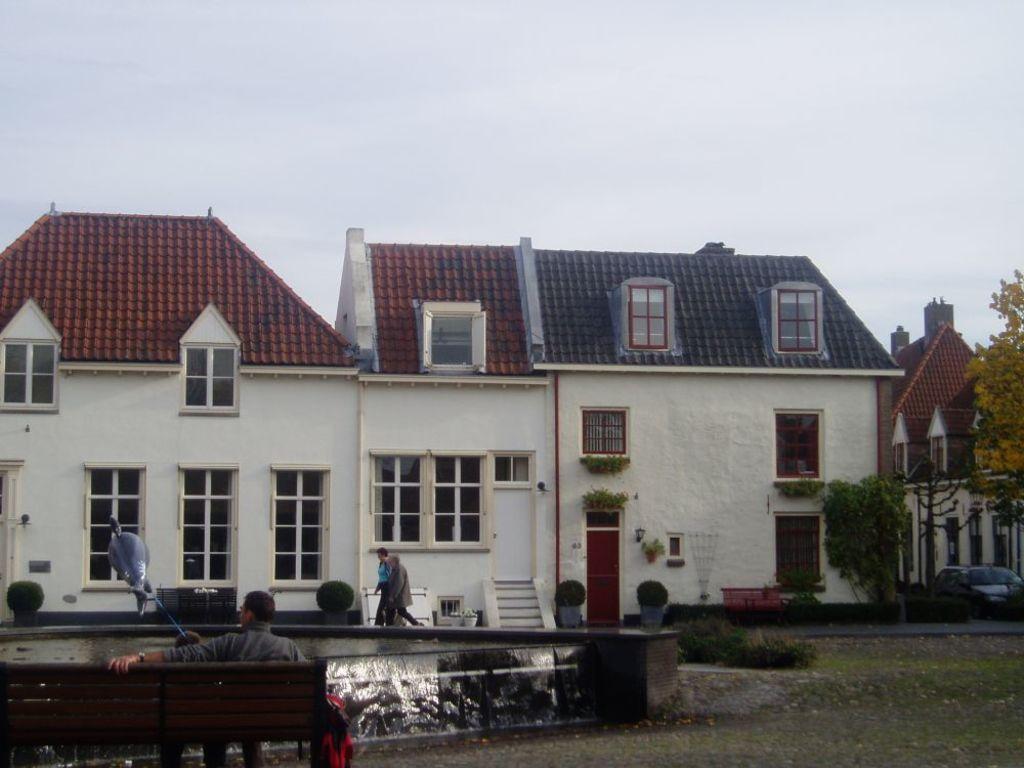How would you summarize this image in a sentence or two? In the center of the image there is a house. There are people walking. There is a bench on which there is a person sitting. At the bottom of the image there is grass. There are trees. At the top of the image there is sky. 